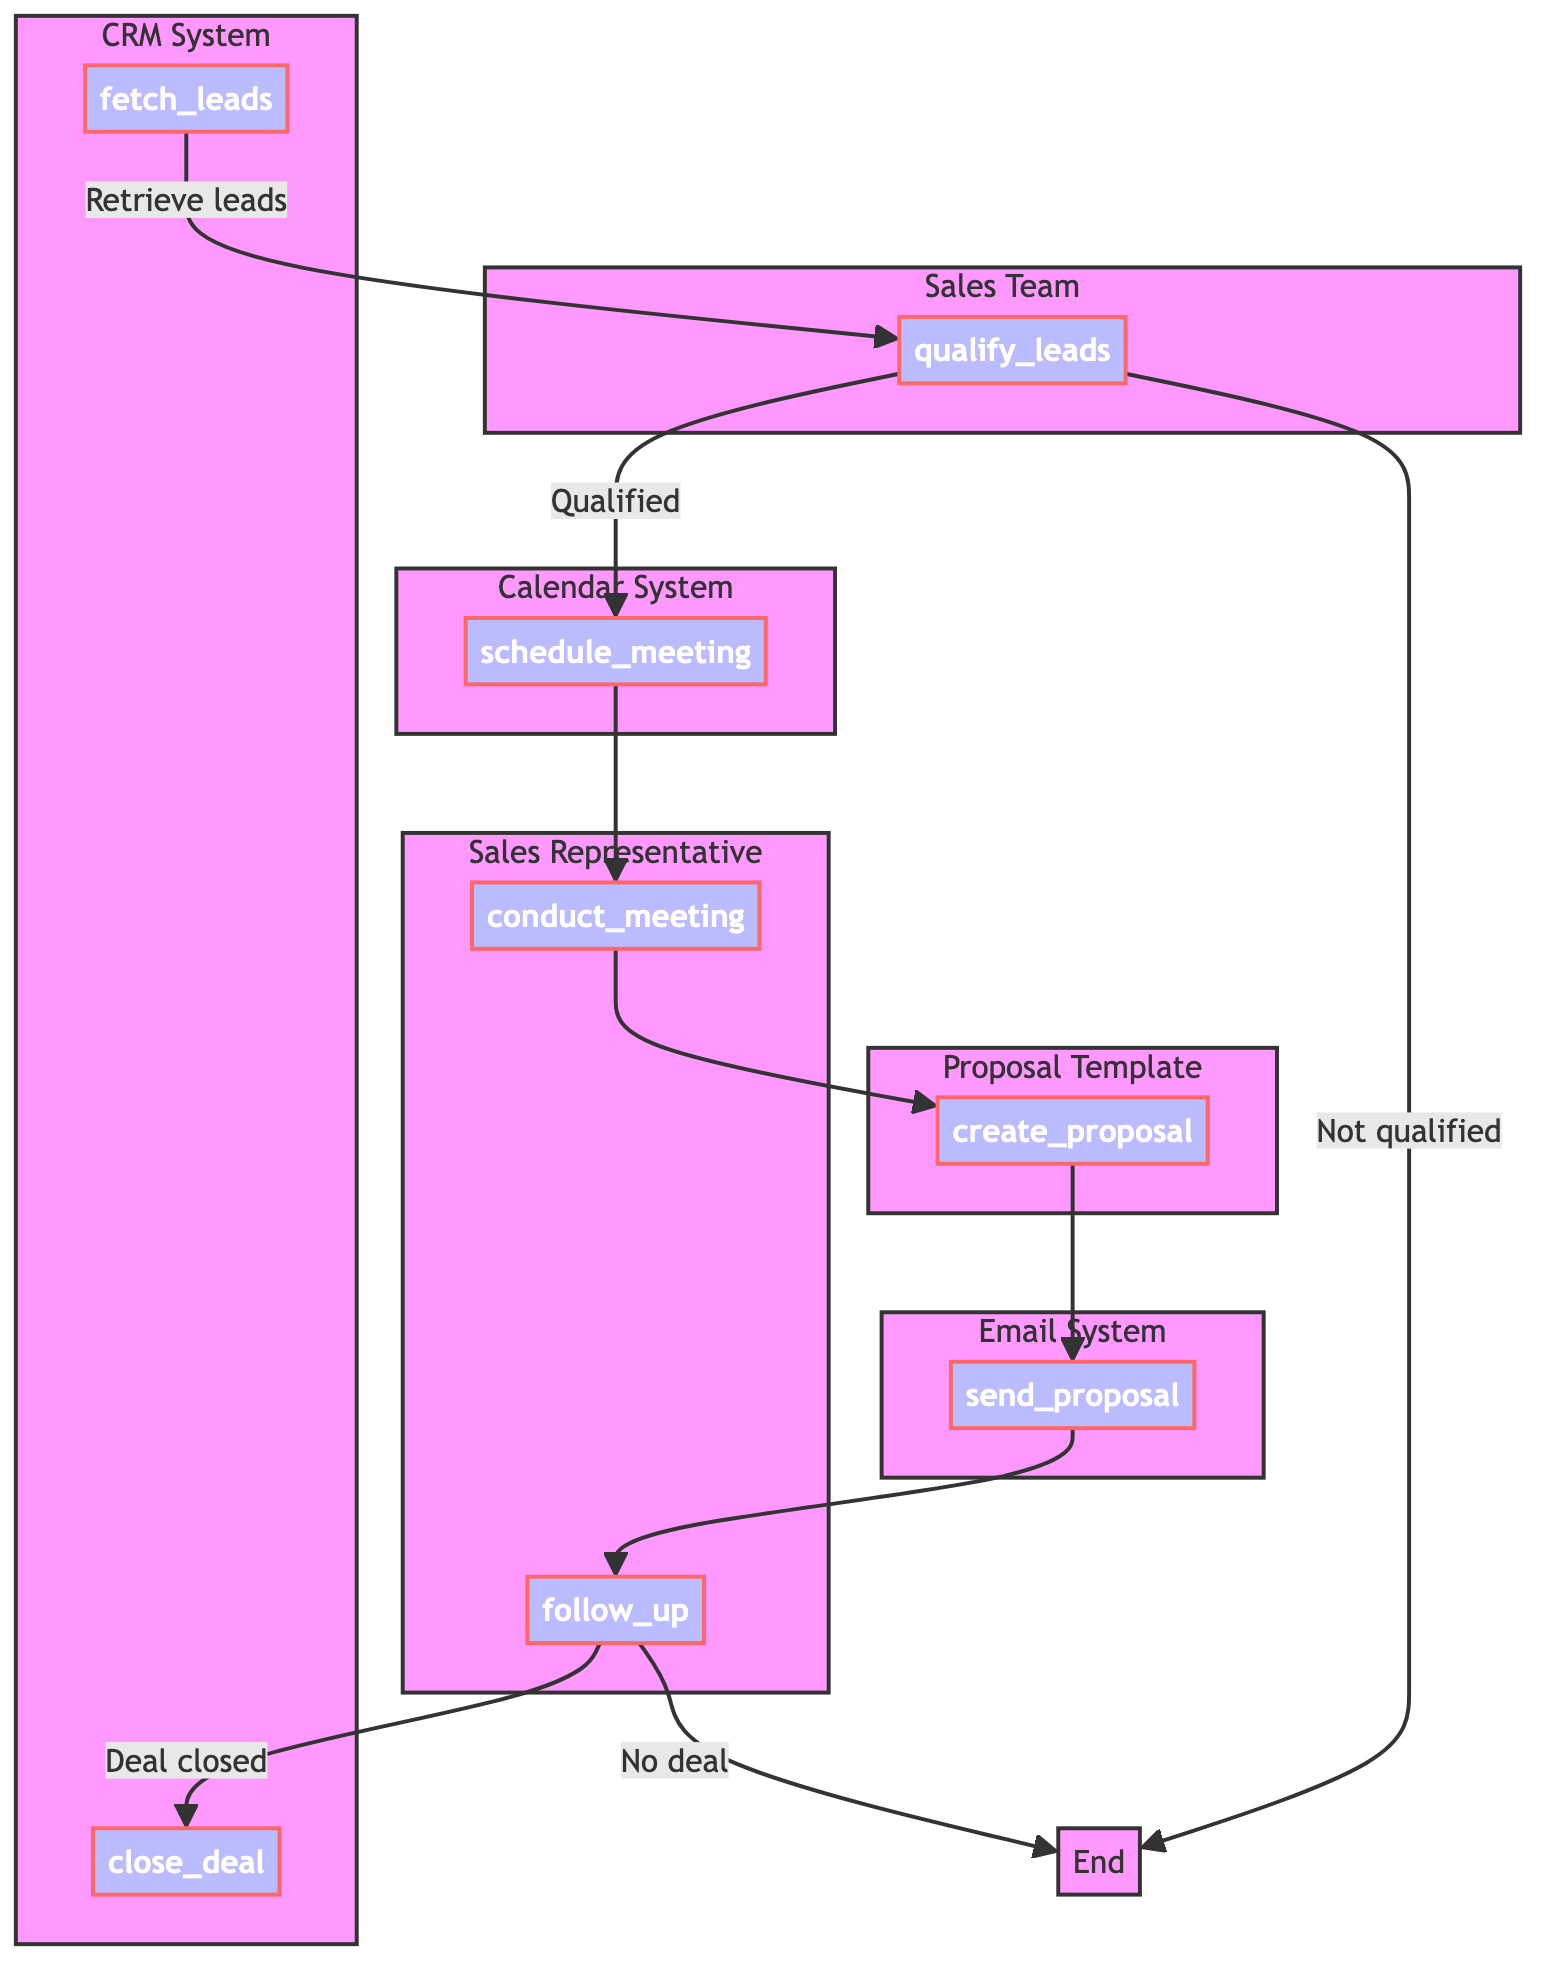What's the first step in the process? The diagram starts with the node 'fetch_leads', which indicates that retrieving leads from the CRM system is the first action taken in the sales pipeline review process.
Answer: fetch leads How many nodes are there in the diagram? There are 8 nodes representing different steps in the process: fetch leads, qualify leads, schedule meeting, conduct meeting, create proposal, send proposal, follow up, and close deal.
Answer: 8 What happens if leads are not qualified? The flowchart shows an arrow from the 'qualify_leads' node to the 'End' node when leads are not qualified, indicating that the process will terminate there for unqualified leads.
Answer: End What does the 'follow_up' node lead to? The 'follow_up' node has two pathways: if the deal is closed, it leads to the 'close_deal' node; if no deal is made, it leads to the 'End' node.
Answer: close deal or End Which entity is responsible for creating the proposal? The 'create_proposal' node is linked to the entity 'Proposal Template', indicating that it is responsible for drafting the proposal based on the previous discussions.
Answer: Proposal Template How many subgraphs are there in the diagram? The diagram contains five subgraphs: CRM System, Sales Team, Calendar System, Sales Representative, and Proposal Template, each representing related entities.
Answer: 5 What is the description of the 'conduct_meeting' node? The 'conduct_meeting' node's description states that it involves holding a meeting with the lead to gather detailed requirements, which is a crucial step for understanding the client's needs.
Answer: Hold meeting and gather requirements Which two nodes are connected directly after the 'schedule_meeting' node? After the 'schedule_meeting' node, the flowchart indicates a direct connection to the 'conduct_meeting' node, signifying that the scheduling of the meeting leads directly to its conduct.
Answer: conduct meeting 